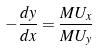Convert formula to latex. <formula><loc_0><loc_0><loc_500><loc_500>- \frac { d y } { d x } = \frac { M U _ { x } } { M U _ { y } }</formula> 